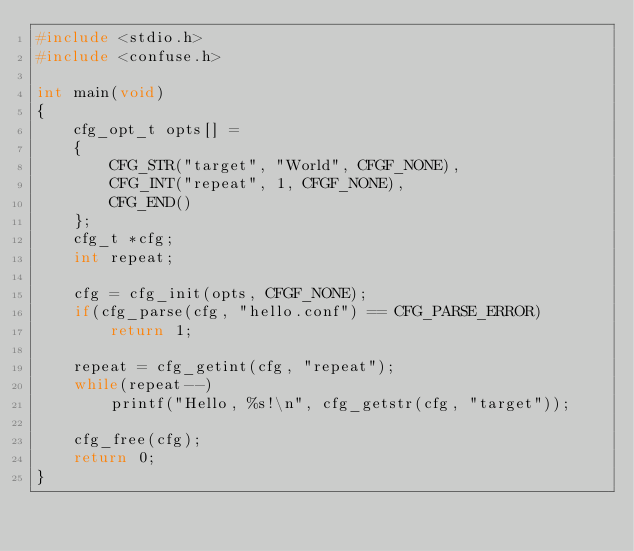<code> <loc_0><loc_0><loc_500><loc_500><_C_>#include <stdio.h>
#include <confuse.h>

int main(void)
{
    cfg_opt_t opts[] =
    {
        CFG_STR("target", "World", CFGF_NONE),
        CFG_INT("repeat", 1, CFGF_NONE),
        CFG_END()
    };
    cfg_t *cfg;
    int repeat;

    cfg = cfg_init(opts, CFGF_NONE);
    if(cfg_parse(cfg, "hello.conf") == CFG_PARSE_ERROR)
        return 1;

    repeat = cfg_getint(cfg, "repeat");
    while(repeat--)
        printf("Hello, %s!\n", cfg_getstr(cfg, "target"));

    cfg_free(cfg);
    return 0;
}

</code> 